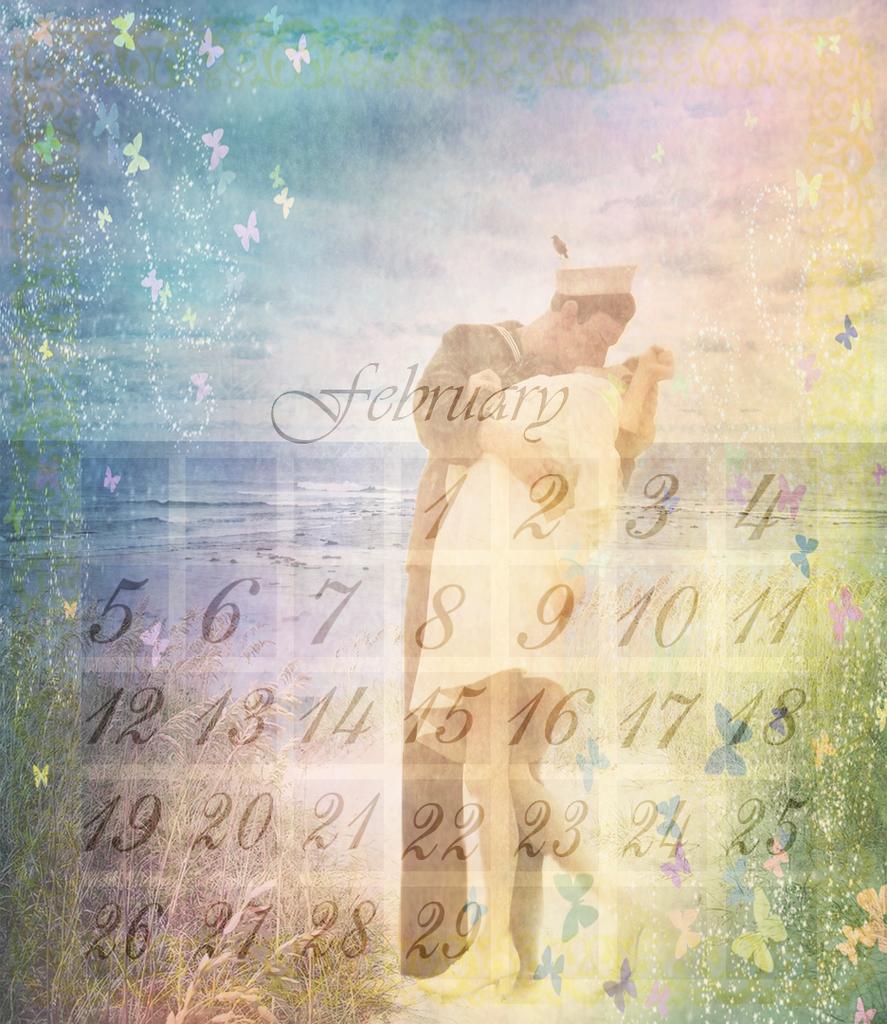In one or two sentences, can you explain what this image depicts? It is an edited image. In this image there is a text, numbers, man, woman, butterflies, sky and water. Man and woman are kissing each other.   